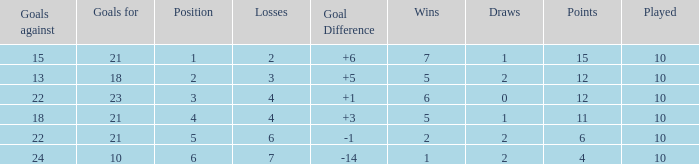Can you tell me the total number of Wins that has the Draws larger than 0, and the Points of 11? 1.0. 